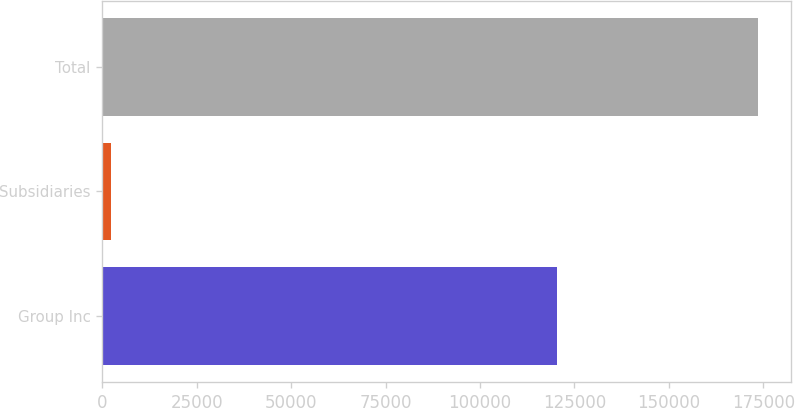<chart> <loc_0><loc_0><loc_500><loc_500><bar_chart><fcel>Group Inc<fcel>Subsidiaries<fcel>Total<nl><fcel>120408<fcel>2219<fcel>173545<nl></chart> 